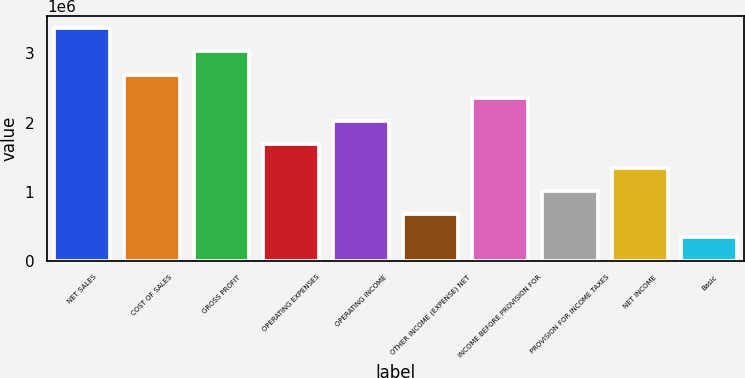Convert chart. <chart><loc_0><loc_0><loc_500><loc_500><bar_chart><fcel>NET SALES<fcel>COST OF SALES<fcel>GROSS PROFIT<fcel>OPERATING EXPENSES<fcel>OPERATING INCOME<fcel>OTHER INCOME (EXPENSE) NET<fcel>INCOME BEFORE PROVISION FOR<fcel>PROVISION FOR INCOME TAXES<fcel>NET INCOME<fcel>Basic<nl><fcel>3.36905e+06<fcel>2.69524e+06<fcel>3.03214e+06<fcel>1.68452e+06<fcel>2.02143e+06<fcel>673810<fcel>2.35833e+06<fcel>1.01071e+06<fcel>1.34762e+06<fcel>336906<nl></chart> 